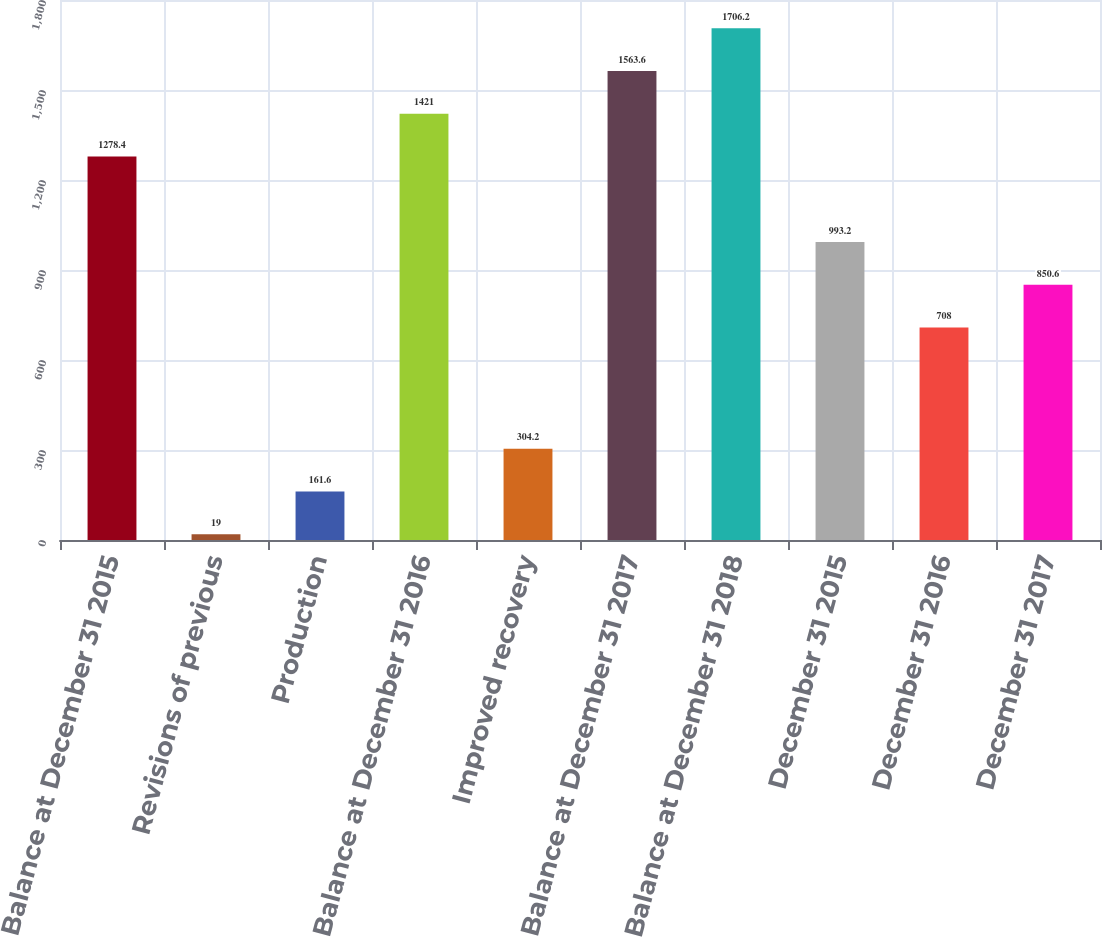Convert chart to OTSL. <chart><loc_0><loc_0><loc_500><loc_500><bar_chart><fcel>Balance at December 31 2015<fcel>Revisions of previous<fcel>Production<fcel>Balance at December 31 2016<fcel>Improved recovery<fcel>Balance at December 31 2017<fcel>Balance at December 31 2018<fcel>December 31 2015<fcel>December 31 2016<fcel>December 31 2017<nl><fcel>1278.4<fcel>19<fcel>161.6<fcel>1421<fcel>304.2<fcel>1563.6<fcel>1706.2<fcel>993.2<fcel>708<fcel>850.6<nl></chart> 